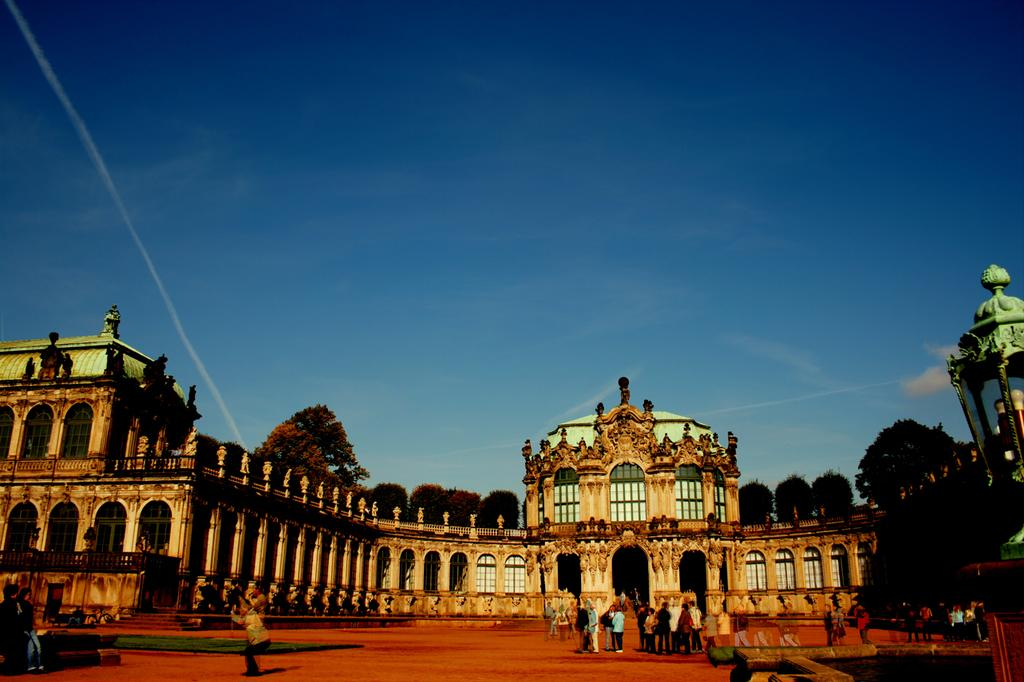What is the main structure in the center of the image? There is a palace in the center of the image. Who or what can be seen at the bottom of the image? There are people at the bottom of the image. What type of vegetation is visible in the background of the image? There are trees in the background of the image. What else can be seen in the background of the image? The sky is visible in the background of the image. What type of pies are being served during the argument in the image? There is no mention of pies or an argument in the image; it features a palace, people, trees, and the sky. 